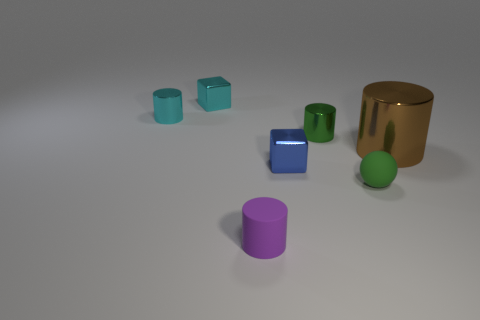Subtract all big cylinders. How many cylinders are left? 3 Subtract all brown cylinders. How many cylinders are left? 3 Subtract 1 spheres. How many spheres are left? 0 Add 3 big objects. How many objects exist? 10 Subtract all blocks. How many objects are left? 5 Subtract all blue cylinders. How many blue cubes are left? 1 Subtract all green blocks. Subtract all brown shiny things. How many objects are left? 6 Add 6 small green balls. How many small green balls are left? 7 Add 6 large metallic cylinders. How many large metallic cylinders exist? 7 Subtract 0 gray cylinders. How many objects are left? 7 